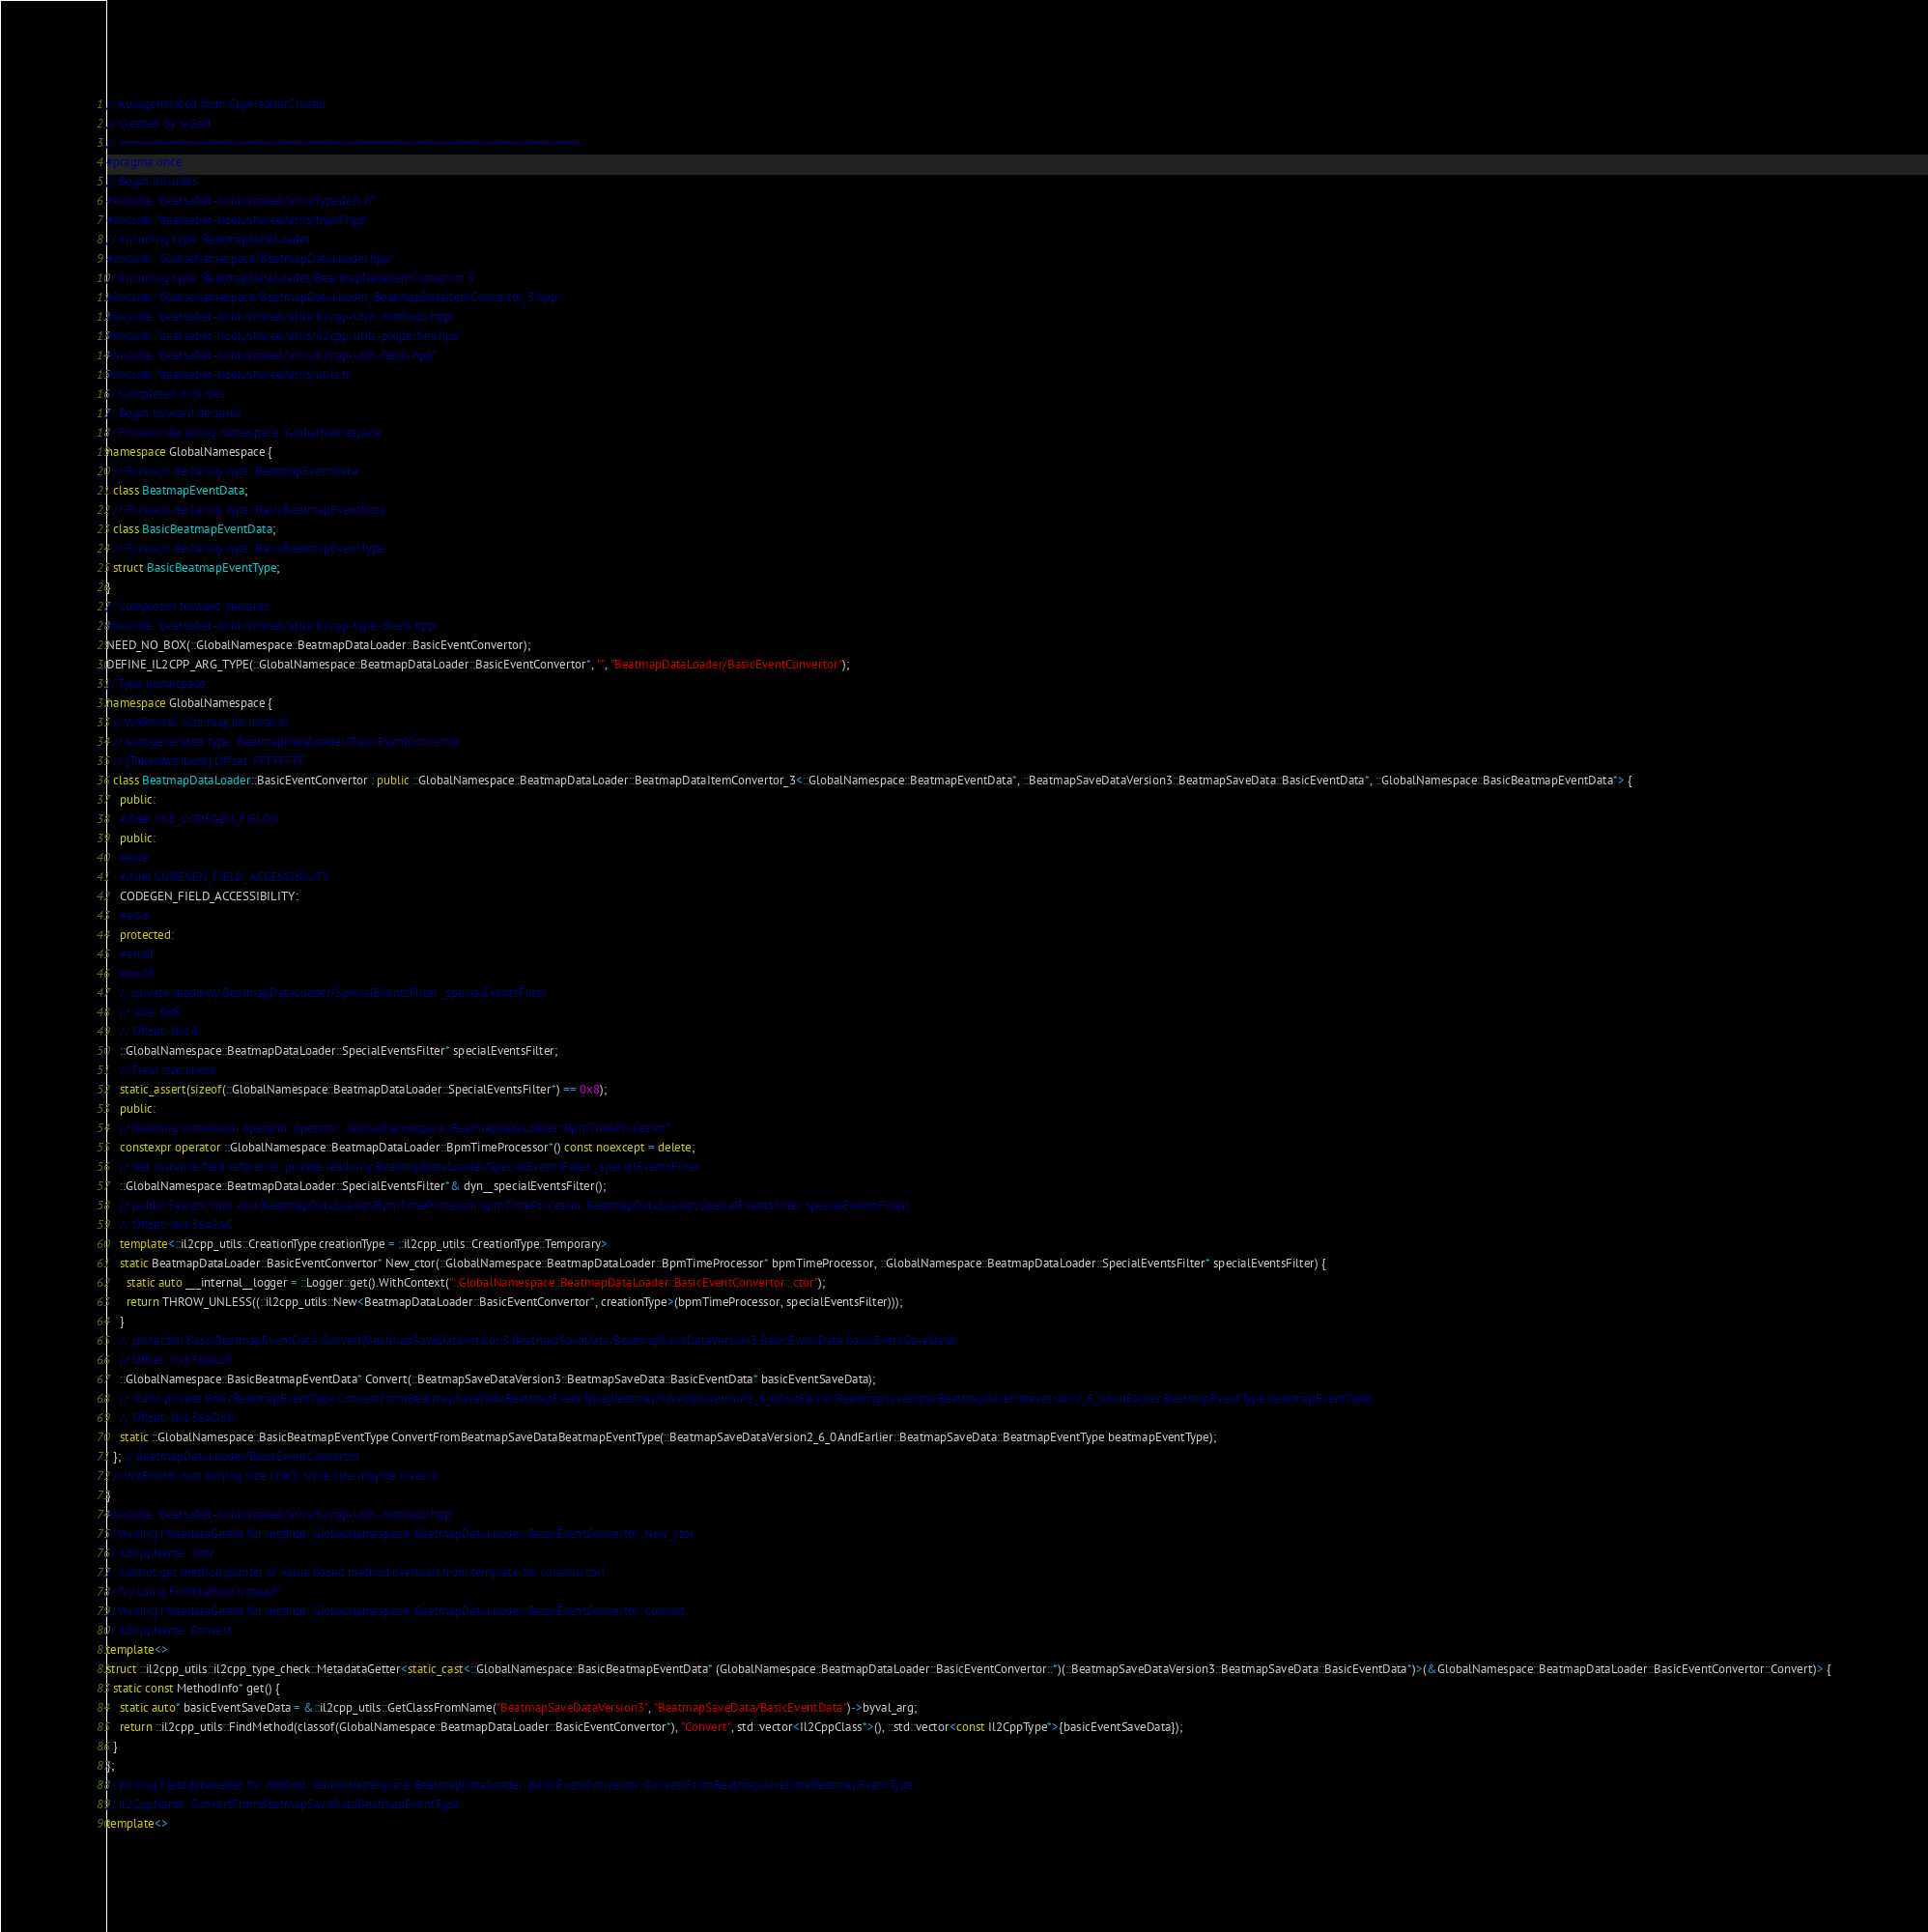<code> <loc_0><loc_0><loc_500><loc_500><_C++_>// Autogenerated from CppHeaderCreator
// Created by Sc2ad
// =========================================================================
#pragma once
// Begin includes
#include "beatsaber-hook/shared/utils/typedefs.h"
#include "beatsaber-hook/shared/utils/byref.hpp"
// Including type: BeatmapDataLoader
#include "GlobalNamespace/BeatmapDataLoader.hpp"
// Including type: BeatmapDataLoader/BeatmapDataItemConvertor`3
#include "GlobalNamespace/BeatmapDataLoader_BeatmapDataItemConvertor_3.hpp"
#include "beatsaber-hook/shared/utils/il2cpp-utils-methods.hpp"
#include "beatsaber-hook/shared/utils/il2cpp-utils-properties.hpp"
#include "beatsaber-hook/shared/utils/il2cpp-utils-fields.hpp"
#include "beatsaber-hook/shared/utils/utils.h"
// Completed includes
// Begin forward declares
// Forward declaring namespace: GlobalNamespace
namespace GlobalNamespace {
  // Forward declaring type: BeatmapEventData
  class BeatmapEventData;
  // Forward declaring type: BasicBeatmapEventData
  class BasicBeatmapEventData;
  // Forward declaring type: BasicBeatmapEventType
  struct BasicBeatmapEventType;
}
// Completed forward declares
#include "beatsaber-hook/shared/utils/il2cpp-type-check.hpp"
NEED_NO_BOX(::GlobalNamespace::BeatmapDataLoader::BasicEventConvertor);
DEFINE_IL2CPP_ARG_TYPE(::GlobalNamespace::BeatmapDataLoader::BasicEventConvertor*, "", "BeatmapDataLoader/BasicEventConvertor");
// Type namespace: 
namespace GlobalNamespace {
  // WARNING Size may be invalid!
  // Autogenerated type: BeatmapDataLoader/BasicEventConvertor
  // [TokenAttribute] Offset: FFFFFFFF
  class BeatmapDataLoader::BasicEventConvertor : public ::GlobalNamespace::BeatmapDataLoader::BeatmapDataItemConvertor_3<::GlobalNamespace::BeatmapEventData*, ::BeatmapSaveDataVersion3::BeatmapSaveData::BasicEventData*, ::GlobalNamespace::BasicBeatmapEventData*> {
    public:
    #ifdef USE_CODEGEN_FIELDS
    public:
    #else
    #ifdef CODEGEN_FIELD_ACCESSIBILITY
    CODEGEN_FIELD_ACCESSIBILITY:
    #else
    protected:
    #endif
    #endif
    // private readonly BeatmapDataLoader/SpecialEventsFilter _specialEventsFilter
    // Size: 0x8
    // Offset: 0x18
    ::GlobalNamespace::BeatmapDataLoader::SpecialEventsFilter* specialEventsFilter;
    // Field size check
    static_assert(sizeof(::GlobalNamespace::BeatmapDataLoader::SpecialEventsFilter*) == 0x8);
    public:
    // Deleting conversion operator: operator ::GlobalNamespace::BeatmapDataLoader::BpmTimeProcessor*
    constexpr operator ::GlobalNamespace::BeatmapDataLoader::BpmTimeProcessor*() const noexcept = delete;
    // Get instance field reference: private readonly BeatmapDataLoader/SpecialEventsFilter _specialEventsFilter
    ::GlobalNamespace::BeatmapDataLoader::SpecialEventsFilter*& dyn__specialEventsFilter();
    // public System.Void .ctor(BeatmapDataLoader/BpmTimeProcessor bpmTimeProcessor, BeatmapDataLoader/SpecialEventsFilter specialEventsFilter)
    // Offset: 0x136A2AC
    template<::il2cpp_utils::CreationType creationType = ::il2cpp_utils::CreationType::Temporary>
    static BeatmapDataLoader::BasicEventConvertor* New_ctor(::GlobalNamespace::BeatmapDataLoader::BpmTimeProcessor* bpmTimeProcessor, ::GlobalNamespace::BeatmapDataLoader::SpecialEventsFilter* specialEventsFilter) {
      static auto ___internal__logger = ::Logger::get().WithContext("::GlobalNamespace::BeatmapDataLoader::BasicEventConvertor::.ctor");
      return THROW_UNLESS((::il2cpp_utils::New<BeatmapDataLoader::BasicEventConvertor*, creationType>(bpmTimeProcessor, specialEventsFilter)));
    }
    // protected BasicBeatmapEventData Convert(BeatmapSaveDataVersion3.BeatmapSaveData/BeatmapSaveDataVersion3.BasicEventData basicEventSaveData)
    // Offset: 0x136AC18
    ::GlobalNamespace::BasicBeatmapEventData* Convert(::BeatmapSaveDataVersion3::BeatmapSaveData::BasicEventData* basicEventSaveData);
    // static private BasicBeatmapEventType ConvertFromBeatmapSaveDataBeatmapEventType(BeatmapSaveDataVersion2_6_0AndEarlier.BeatmapSaveData/BeatmapSaveDataVersion2_6_0AndEarlier.BeatmapEventType beatmapEventType)
    // Offset: 0x136AD58
    static ::GlobalNamespace::BasicBeatmapEventType ConvertFromBeatmapSaveDataBeatmapEventType(::BeatmapSaveDataVersion2_6_0AndEarlier::BeatmapSaveData::BeatmapEventType beatmapEventType);
  }; // BeatmapDataLoader/BasicEventConvertor
  // WARNING Not writing size check since size may be invalid!
}
#include "beatsaber-hook/shared/utils/il2cpp-utils-methods.hpp"
// Writing MetadataGetter for method: GlobalNamespace::BeatmapDataLoader::BasicEventConvertor::New_ctor
// Il2CppName: .ctor
// Cannot get method pointer of value based method overload from template for constructor!
// Try using FindMethod instead!
// Writing MetadataGetter for method: GlobalNamespace::BeatmapDataLoader::BasicEventConvertor::Convert
// Il2CppName: Convert
template<>
struct ::il2cpp_utils::il2cpp_type_check::MetadataGetter<static_cast<::GlobalNamespace::BasicBeatmapEventData* (GlobalNamespace::BeatmapDataLoader::BasicEventConvertor::*)(::BeatmapSaveDataVersion3::BeatmapSaveData::BasicEventData*)>(&GlobalNamespace::BeatmapDataLoader::BasicEventConvertor::Convert)> {
  static const MethodInfo* get() {
    static auto* basicEventSaveData = &::il2cpp_utils::GetClassFromName("BeatmapSaveDataVersion3", "BeatmapSaveData/BasicEventData")->byval_arg;
    return ::il2cpp_utils::FindMethod(classof(GlobalNamespace::BeatmapDataLoader::BasicEventConvertor*), "Convert", std::vector<Il2CppClass*>(), ::std::vector<const Il2CppType*>{basicEventSaveData});
  }
};
// Writing MetadataGetter for method: GlobalNamespace::BeatmapDataLoader::BasicEventConvertor::ConvertFromBeatmapSaveDataBeatmapEventType
// Il2CppName: ConvertFromBeatmapSaveDataBeatmapEventType
template<></code> 